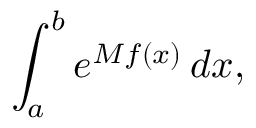Convert formula to latex. <formula><loc_0><loc_0><loc_500><loc_500>\int _ { a } ^ { b } e ^ { M f ( x ) } \, d x ,</formula> 